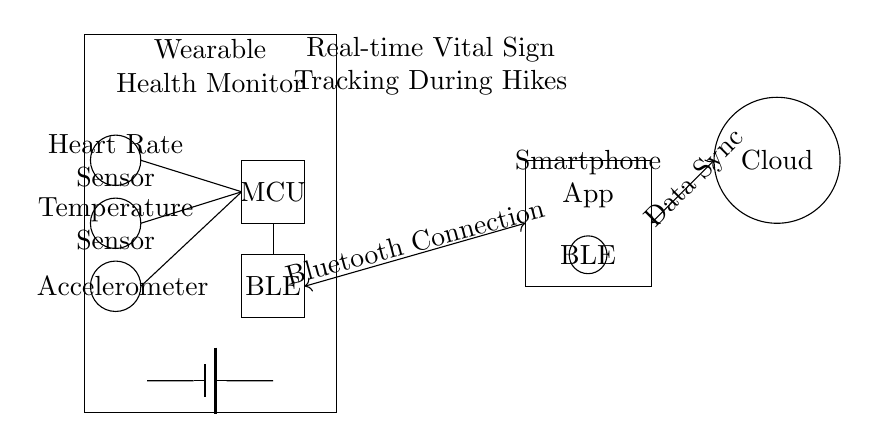What is the main function of the wearable health monitor? The wearable health monitor tracks vital signs such as heart rate, body temperature, and movement during hikes. These functions can be deduced by identifying the sensors present in the circuit, including a heart rate sensor, temperature sensor, and accelerometer.
Answer: tracking vital signs What type of connectivity does this wearable device use? The wearable device uses Bluetooth Low Energy, indicated by the label "BLE" on the diagram, which is commonly used for communication between low-power devices. This is further confirmed by the connection to the smartphone, which also includes a BLE module.
Answer: Bluetooth Low Energy How many sensors are represented in the circuit diagram? The circuit diagram contains three sensors: a heart rate sensor, a temperature sensor, and an accelerometer. Each sensor is visually represented by a circle and labeled within the wearable device's rectangle, allowing easy counting.
Answer: three What component is responsible for processing data in this circuit? The microcontroller unit (MCU) processes data collected from the sensors. It is labeled in the circuit diagram and draws connections to the sensors, indicating its role in handling the sensor outputs before transmitting data via Bluetooth.
Answer: microcontroller unit What type of data synchronization is depicted in the circuit? The circuit includes data synchronization with the cloud, as indicated by the connection between the smartphone app and the cloud. The diagram highlights a bidirectional data link, suggesting real-time updates and storage for health data in the cloud.
Answer: data synchronization Which component supplies power to the wearable health monitor? The battery serves as the power supply for the wearable health monitor, as indicated by the battery symbol in the circuit diagram. It connects to the components within the wearable device, providing the necessary voltage for operation.
Answer: battery What is the overall purpose of the Bluetooth connection in this circuit? The Bluetooth connection enables wireless communication between the wearable health monitor and the smartphone app, allowing real-time vital sign tracking and data transfer. This is indicated by the labeled connection between the wearable's Bluetooth module and the smartphone's BLE.
Answer: wireless communication 